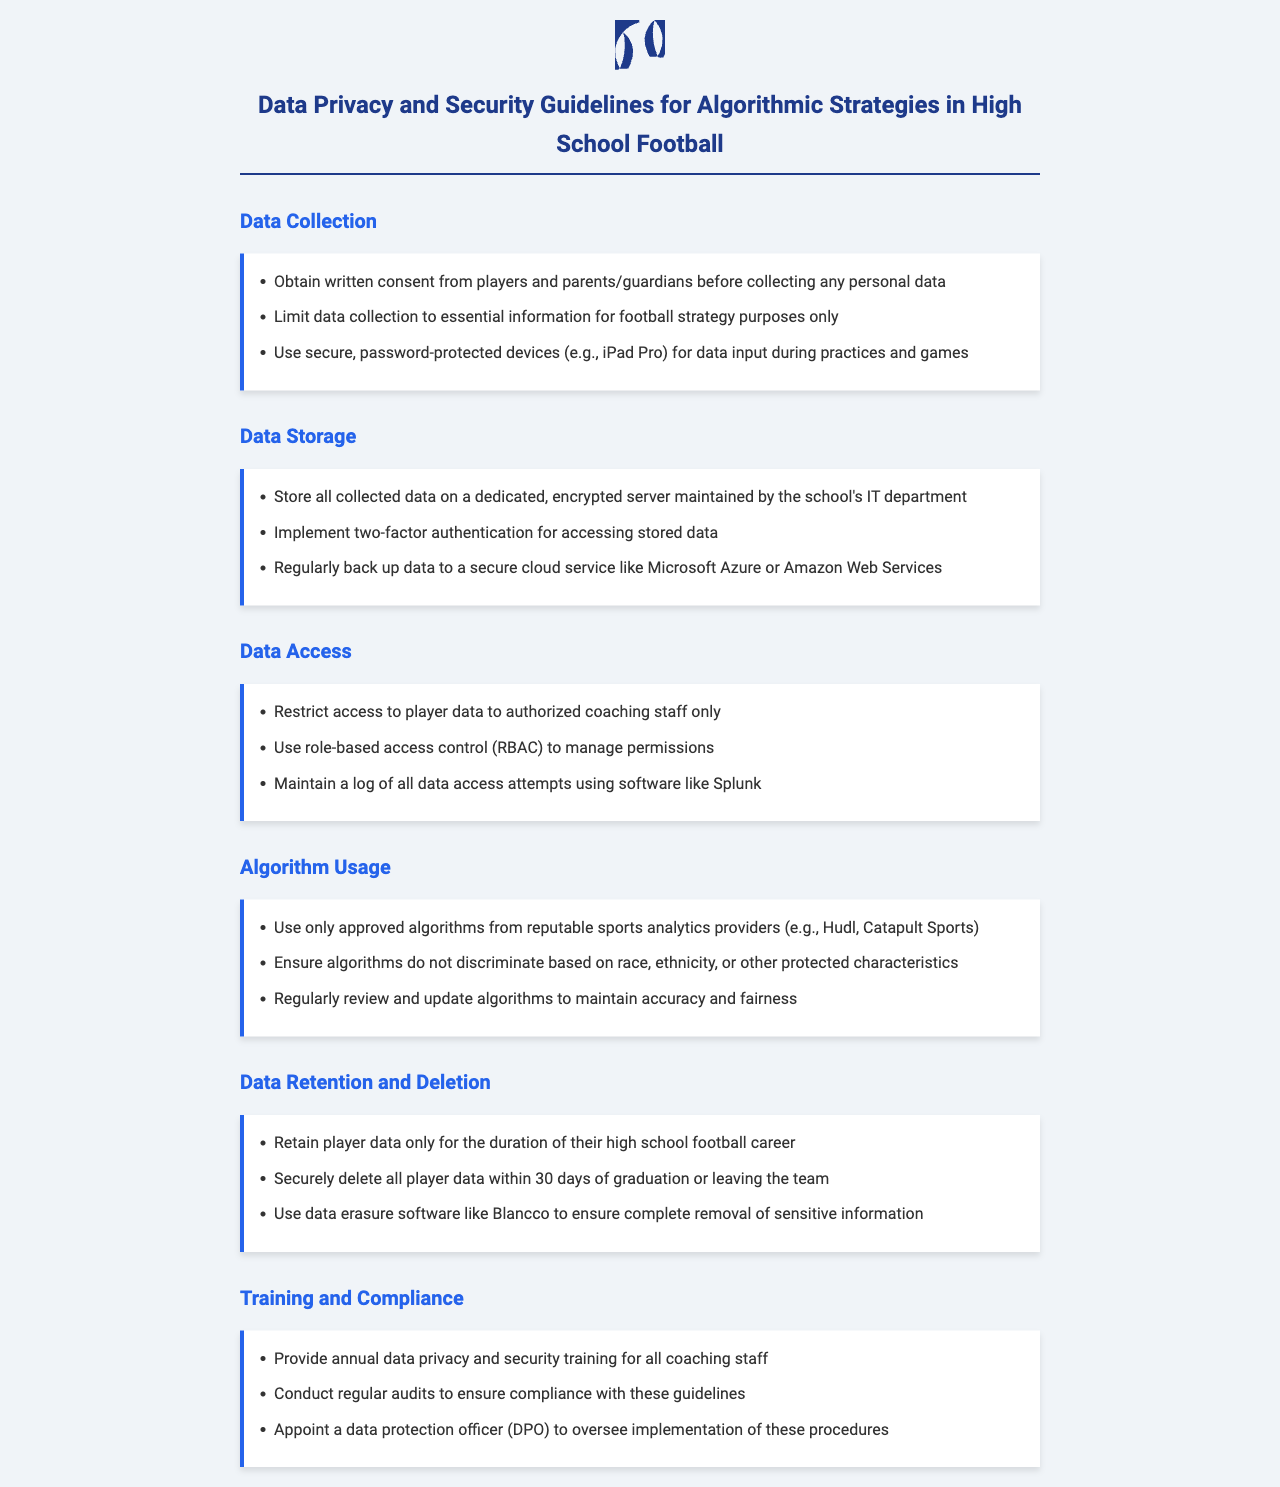What is required before collecting personal data? The document states that written consent from players and parents/guardians is necessary before collecting personal data.
Answer: written consent Where should collected data be stored? The document specifies that all collected data should be stored on a dedicated, encrypted server maintained by the school's IT department.
Answer: encrypted server Who can access player data? According to the guidelines, access to player data is restricted to authorized coaching staff only.
Answer: authorized coaching staff What software should be used for logging data access attempts? The document mentions using software like Splunk to maintain a log of all data access attempts.
Answer: Splunk How long should player data be retained? The guidelines indicate that player data should be retained only for the duration of their high school football career.
Answer: duration of their high school football career What kind of training is required for coaching staff? The document states that annual data privacy and security training is required for all coaching staff.
Answer: annual training What is the purpose of using role-based access control? The document outlines that role-based access control (RBAC) is used to manage permissions for accessing player data.
Answer: manage permissions Which organizations should provide approved algorithms? The document specifies using approved algorithms from reputable sports analytics providers like Hudl and Catapult Sports.
Answer: Hudl, Catapult Sports What should be done with player data after graduation? The guidelines dictate that all player data should be securely deleted within 30 days of graduation or leaving the team.
Answer: securely deleted within 30 days 